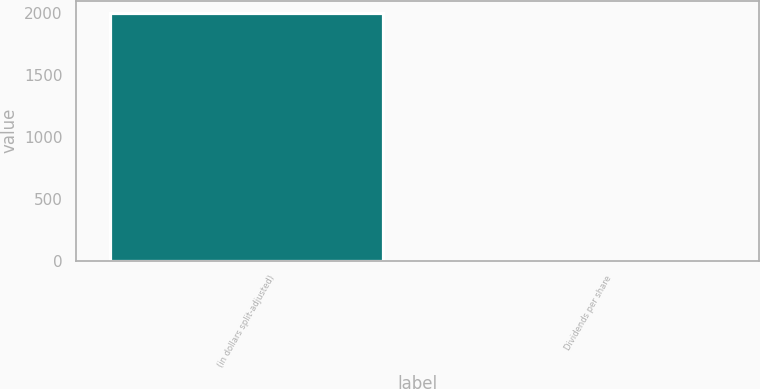<chart> <loc_0><loc_0><loc_500><loc_500><bar_chart><fcel>(in dollars split-adjusted)<fcel>Dividends per share<nl><fcel>1997<fcel>0.45<nl></chart> 